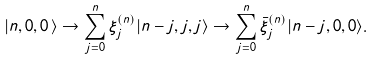<formula> <loc_0><loc_0><loc_500><loc_500>| n , 0 , 0 \, \rangle \rightarrow \sum _ { j = 0 } ^ { n } { \xi } ^ { ( n ) } _ { j } | n - j , j , j \rangle \rightarrow \sum _ { j = 0 } ^ { n } { \bar { \xi } } ^ { ( n ) } _ { j } | n - j , 0 , 0 \rangle .</formula> 